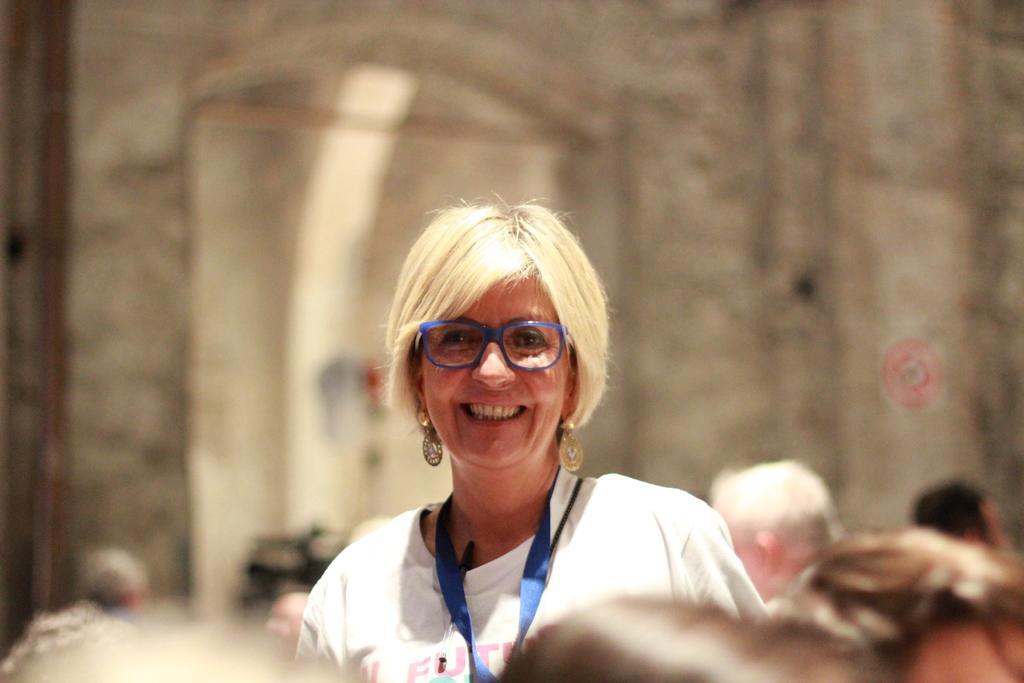Describe this image in one or two sentences. In this image there are group of persons truncated towards the bottom of the image, there is a person truncated towards the right of the image, there is an object behind the persons, at the background of the image there is a wall truncated. 